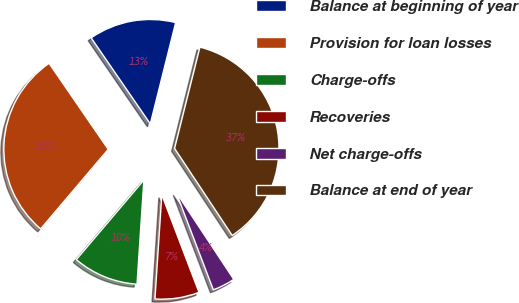Convert chart to OTSL. <chart><loc_0><loc_0><loc_500><loc_500><pie_chart><fcel>Balance at beginning of year<fcel>Provision for loan losses<fcel>Charge-offs<fcel>Recoveries<fcel>Net charge-offs<fcel>Balance at end of year<nl><fcel>13.49%<fcel>29.21%<fcel>10.16%<fcel>6.84%<fcel>3.51%<fcel>36.79%<nl></chart> 